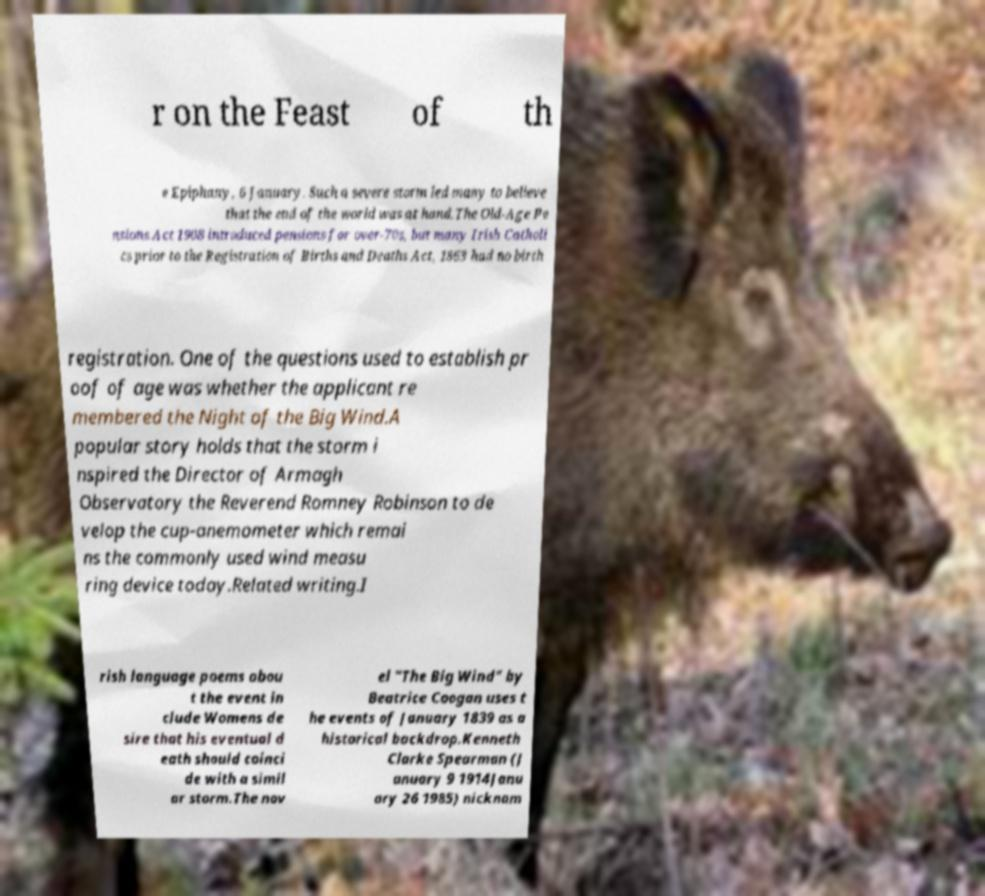For documentation purposes, I need the text within this image transcribed. Could you provide that? r on the Feast of th e Epiphany, 6 January. Such a severe storm led many to believe that the end of the world was at hand.The Old-Age Pe nsions Act 1908 introduced pensions for over-70s, but many Irish Catholi cs prior to the Registration of Births and Deaths Act, 1863 had no birth registration. One of the questions used to establish pr oof of age was whether the applicant re membered the Night of the Big Wind.A popular story holds that the storm i nspired the Director of Armagh Observatory the Reverend Romney Robinson to de velop the cup-anemometer which remai ns the commonly used wind measu ring device today.Related writing.I rish language poems abou t the event in clude Womens de sire that his eventual d eath should coinci de with a simil ar storm.The nov el "The Big Wind" by Beatrice Coogan uses t he events of January 1839 as a historical backdrop.Kenneth Clarke Spearman (J anuary 9 1914Janu ary 26 1985) nicknam 